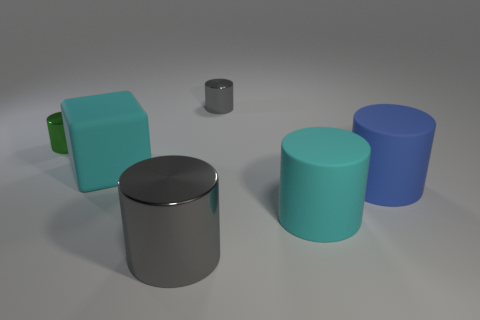There is a blue matte cylinder; is it the same size as the gray shiny object that is behind the large matte block?
Provide a succinct answer. No. How many rubber things are large cyan objects or blue cylinders?
Your answer should be compact. 3. Are there more big cyan cubes than small cyan cylinders?
Your answer should be very brief. Yes. There is a thing that is the same color as the matte block; what is its size?
Offer a terse response. Large. The big cyan thing that is in front of the big cyan thing behind the big blue thing is what shape?
Offer a terse response. Cylinder. Are there any tiny green shiny objects behind the object that is behind the tiny metallic thing that is left of the large cyan cube?
Keep it short and to the point. No. The other metallic cylinder that is the same size as the blue cylinder is what color?
Your answer should be very brief. Gray. What is the shape of the large object that is both to the right of the large gray thing and in front of the blue cylinder?
Your answer should be very brief. Cylinder. What is the size of the gray metal cylinder in front of the gray cylinder behind the large blue cylinder?
Your response must be concise. Large. How many tiny metallic cylinders are the same color as the big cube?
Your response must be concise. 0. 